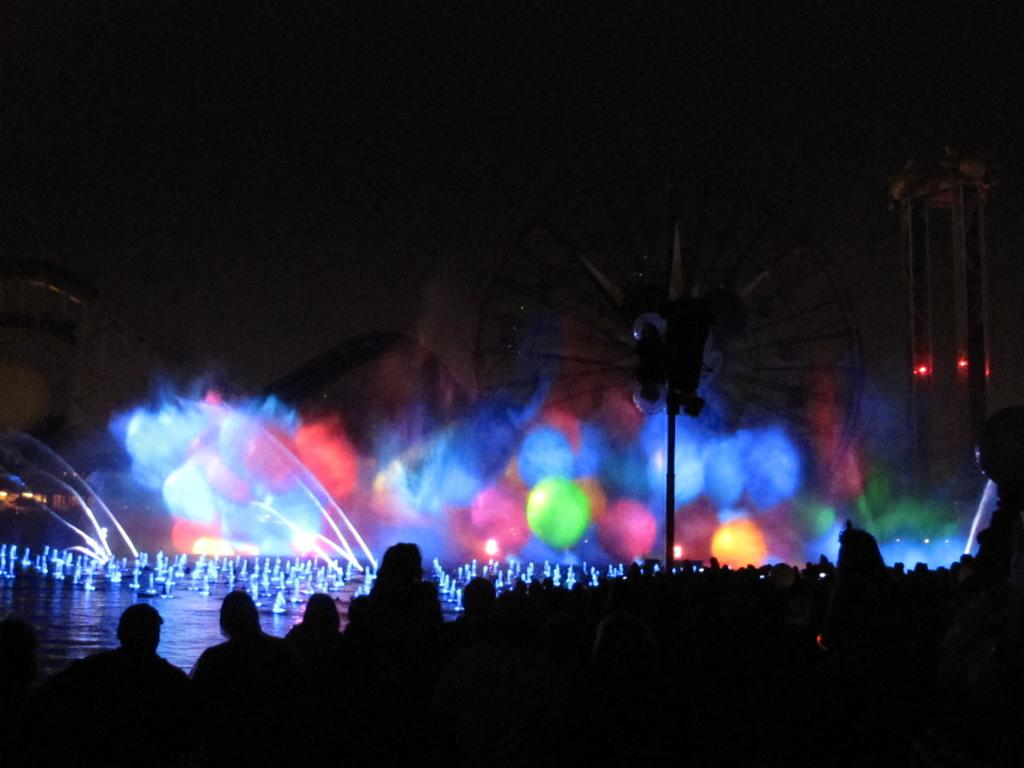Who or what can be seen in the image? There are people in the image. Can you describe the lighting in the image? The image appears to be dark. What can be said about the background of the image? There is a colorful background in the image. What color is the cow in the middle of the image? There is no cow present in the image. 